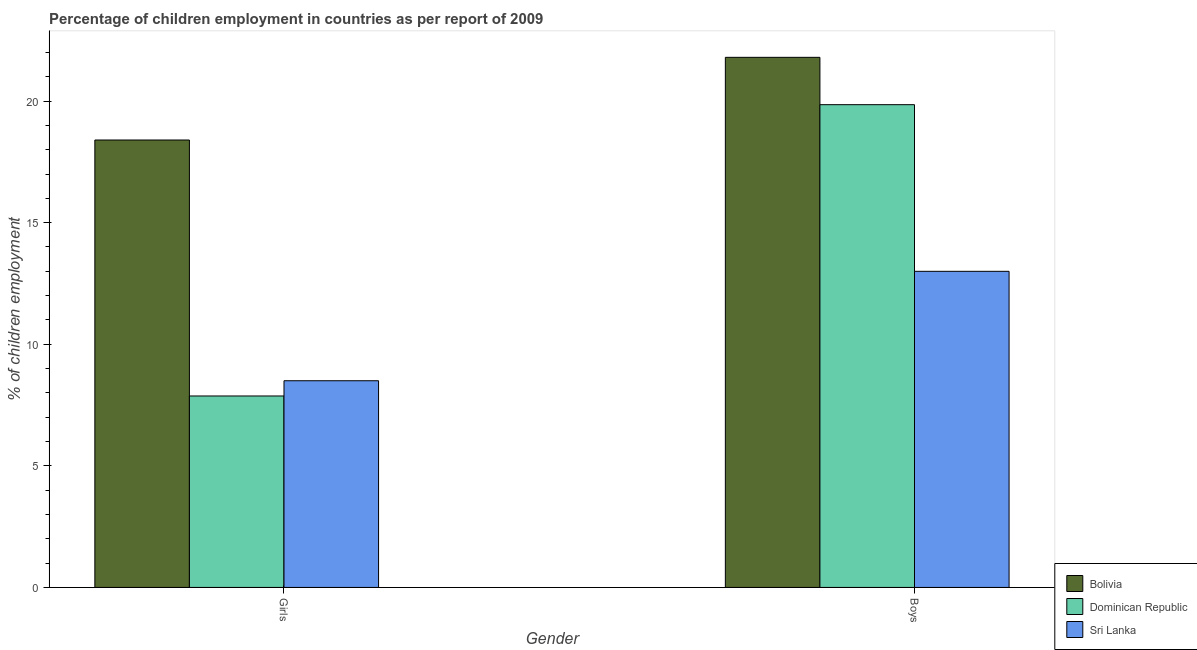How many groups of bars are there?
Ensure brevity in your answer.  2. Are the number of bars per tick equal to the number of legend labels?
Your answer should be compact. Yes. How many bars are there on the 2nd tick from the left?
Offer a very short reply. 3. How many bars are there on the 1st tick from the right?
Offer a terse response. 3. What is the label of the 1st group of bars from the left?
Give a very brief answer. Girls. What is the percentage of employed girls in Dominican Republic?
Your response must be concise. 7.87. Across all countries, what is the maximum percentage of employed girls?
Provide a short and direct response. 18.4. Across all countries, what is the minimum percentage of employed girls?
Provide a short and direct response. 7.87. In which country was the percentage of employed girls maximum?
Provide a succinct answer. Bolivia. In which country was the percentage of employed boys minimum?
Your answer should be very brief. Sri Lanka. What is the total percentage of employed girls in the graph?
Offer a terse response. 34.77. What is the difference between the percentage of employed boys in Bolivia and that in Dominican Republic?
Ensure brevity in your answer.  1.95. What is the difference between the percentage of employed girls in Bolivia and the percentage of employed boys in Dominican Republic?
Make the answer very short. -1.45. What is the average percentage of employed girls per country?
Provide a short and direct response. 11.59. What is the difference between the percentage of employed girls and percentage of employed boys in Dominican Republic?
Offer a very short reply. -11.98. What is the ratio of the percentage of employed boys in Sri Lanka to that in Bolivia?
Ensure brevity in your answer.  0.6. What does the 3rd bar from the left in Boys represents?
Offer a terse response. Sri Lanka. Are all the bars in the graph horizontal?
Your response must be concise. No. How many countries are there in the graph?
Make the answer very short. 3. What is the difference between two consecutive major ticks on the Y-axis?
Provide a short and direct response. 5. Are the values on the major ticks of Y-axis written in scientific E-notation?
Offer a very short reply. No. Does the graph contain grids?
Give a very brief answer. No. Where does the legend appear in the graph?
Your answer should be very brief. Bottom right. How are the legend labels stacked?
Provide a short and direct response. Vertical. What is the title of the graph?
Give a very brief answer. Percentage of children employment in countries as per report of 2009. What is the label or title of the X-axis?
Your answer should be very brief. Gender. What is the label or title of the Y-axis?
Ensure brevity in your answer.  % of children employment. What is the % of children employment in Dominican Republic in Girls?
Provide a short and direct response. 7.87. What is the % of children employment in Bolivia in Boys?
Ensure brevity in your answer.  21.8. What is the % of children employment of Dominican Republic in Boys?
Provide a short and direct response. 19.85. Across all Gender, what is the maximum % of children employment in Bolivia?
Ensure brevity in your answer.  21.8. Across all Gender, what is the maximum % of children employment of Dominican Republic?
Offer a very short reply. 19.85. Across all Gender, what is the minimum % of children employment of Bolivia?
Keep it short and to the point. 18.4. Across all Gender, what is the minimum % of children employment in Dominican Republic?
Offer a very short reply. 7.87. What is the total % of children employment in Bolivia in the graph?
Make the answer very short. 40.2. What is the total % of children employment in Dominican Republic in the graph?
Make the answer very short. 27.73. What is the total % of children employment in Sri Lanka in the graph?
Your answer should be very brief. 21.5. What is the difference between the % of children employment in Bolivia in Girls and that in Boys?
Make the answer very short. -3.4. What is the difference between the % of children employment in Dominican Republic in Girls and that in Boys?
Offer a terse response. -11.98. What is the difference between the % of children employment of Bolivia in Girls and the % of children employment of Dominican Republic in Boys?
Offer a very short reply. -1.45. What is the difference between the % of children employment of Bolivia in Girls and the % of children employment of Sri Lanka in Boys?
Offer a very short reply. 5.4. What is the difference between the % of children employment in Dominican Republic in Girls and the % of children employment in Sri Lanka in Boys?
Your answer should be compact. -5.13. What is the average % of children employment of Bolivia per Gender?
Give a very brief answer. 20.1. What is the average % of children employment in Dominican Republic per Gender?
Make the answer very short. 13.86. What is the average % of children employment of Sri Lanka per Gender?
Your response must be concise. 10.75. What is the difference between the % of children employment of Bolivia and % of children employment of Dominican Republic in Girls?
Ensure brevity in your answer.  10.53. What is the difference between the % of children employment of Bolivia and % of children employment of Sri Lanka in Girls?
Offer a terse response. 9.9. What is the difference between the % of children employment in Dominican Republic and % of children employment in Sri Lanka in Girls?
Give a very brief answer. -0.63. What is the difference between the % of children employment in Bolivia and % of children employment in Dominican Republic in Boys?
Ensure brevity in your answer.  1.95. What is the difference between the % of children employment of Dominican Republic and % of children employment of Sri Lanka in Boys?
Keep it short and to the point. 6.85. What is the ratio of the % of children employment in Bolivia in Girls to that in Boys?
Offer a very short reply. 0.84. What is the ratio of the % of children employment in Dominican Republic in Girls to that in Boys?
Your answer should be compact. 0.4. What is the ratio of the % of children employment of Sri Lanka in Girls to that in Boys?
Your answer should be very brief. 0.65. What is the difference between the highest and the second highest % of children employment of Dominican Republic?
Your answer should be compact. 11.98. What is the difference between the highest and the lowest % of children employment of Bolivia?
Provide a succinct answer. 3.4. What is the difference between the highest and the lowest % of children employment of Dominican Republic?
Offer a very short reply. 11.98. What is the difference between the highest and the lowest % of children employment of Sri Lanka?
Offer a terse response. 4.5. 